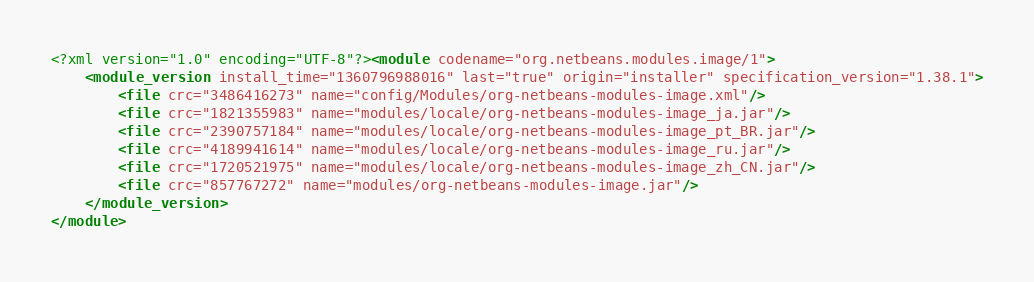<code> <loc_0><loc_0><loc_500><loc_500><_XML_><?xml version="1.0" encoding="UTF-8"?><module codename="org.netbeans.modules.image/1">
    <module_version install_time="1360796988016" last="true" origin="installer" specification_version="1.38.1">
        <file crc="3486416273" name="config/Modules/org-netbeans-modules-image.xml"/>
        <file crc="1821355983" name="modules/locale/org-netbeans-modules-image_ja.jar"/>
        <file crc="2390757184" name="modules/locale/org-netbeans-modules-image_pt_BR.jar"/>
        <file crc="4189941614" name="modules/locale/org-netbeans-modules-image_ru.jar"/>
        <file crc="1720521975" name="modules/locale/org-netbeans-modules-image_zh_CN.jar"/>
        <file crc="857767272" name="modules/org-netbeans-modules-image.jar"/>
    </module_version>
</module>
</code> 